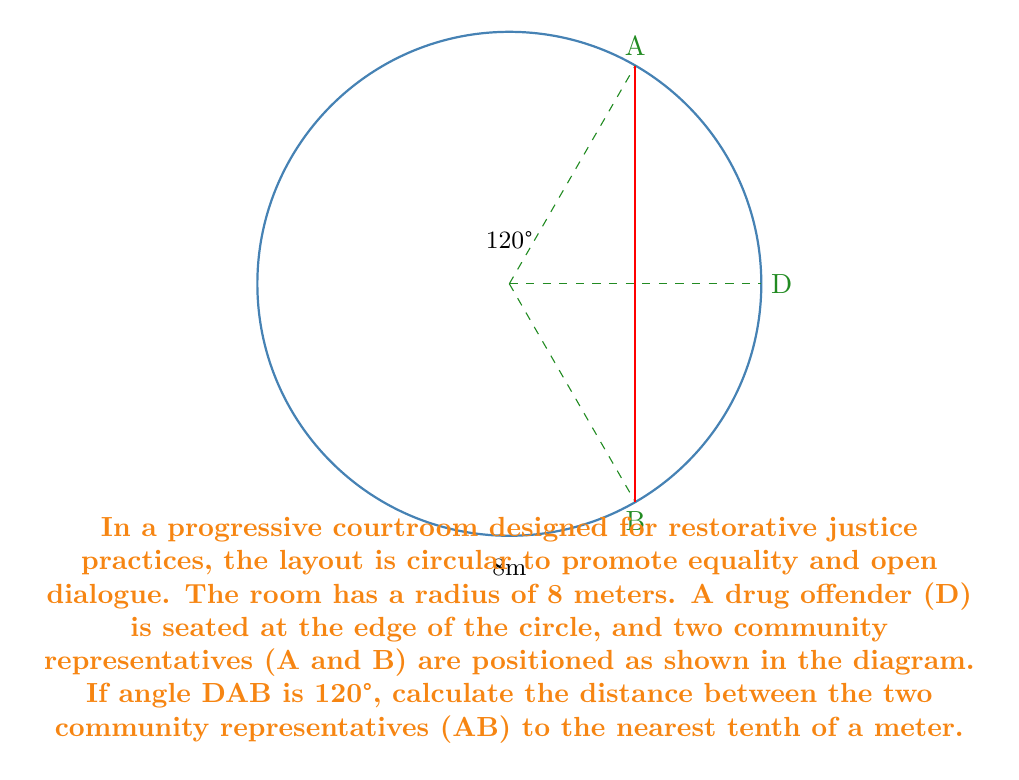Show me your answer to this math problem. Let's approach this step-by-step:

1) In this circular courtroom, O is the center, and OD, OA, and OB are all radii of the circle, each 8 meters long.

2) The angle DAB is given as 120°. Since OA and OB are radii, they form an isosceles triangle with AB. The angle AOB at the center is therefore twice the angle DAB:

   $\angle AOB = 2 \times \angle DAB = 2 \times 120° = 240°$

3) We can now use the cosine law to find the length of AB. The cosine law states:

   $c^2 = a^2 + b^2 - 2ab \cos(C)$

   Where c is the side we're looking for (AB), a and b are the other two sides (OA and OB), and C is the angle opposite to side c (angle AOB).

4) Substituting our values:

   $AB^2 = 8^2 + 8^2 - 2(8)(8) \cos(240°)$

5) Simplify:

   $AB^2 = 64 + 64 - 128 \cos(240°)$

6) $\cos(240°) = -\frac{1}{2}$, so:

   $AB^2 = 64 + 64 - 128(-\frac{1}{2}) = 64 + 64 + 64 = 192$

7) Take the square root of both sides:

   $AB = \sqrt{192} \approx 13.8564$

8) Rounding to the nearest tenth:

   $AB \approx 13.9$ meters
Answer: 13.9 m 